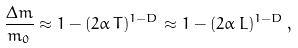<formula> <loc_0><loc_0><loc_500><loc_500>\frac { \Delta m } { m _ { 0 } } \approx 1 - ( 2 \alpha \, T ) ^ { 1 - D } \approx 1 - ( 2 \alpha \, L ) ^ { 1 - D } \, ,</formula> 